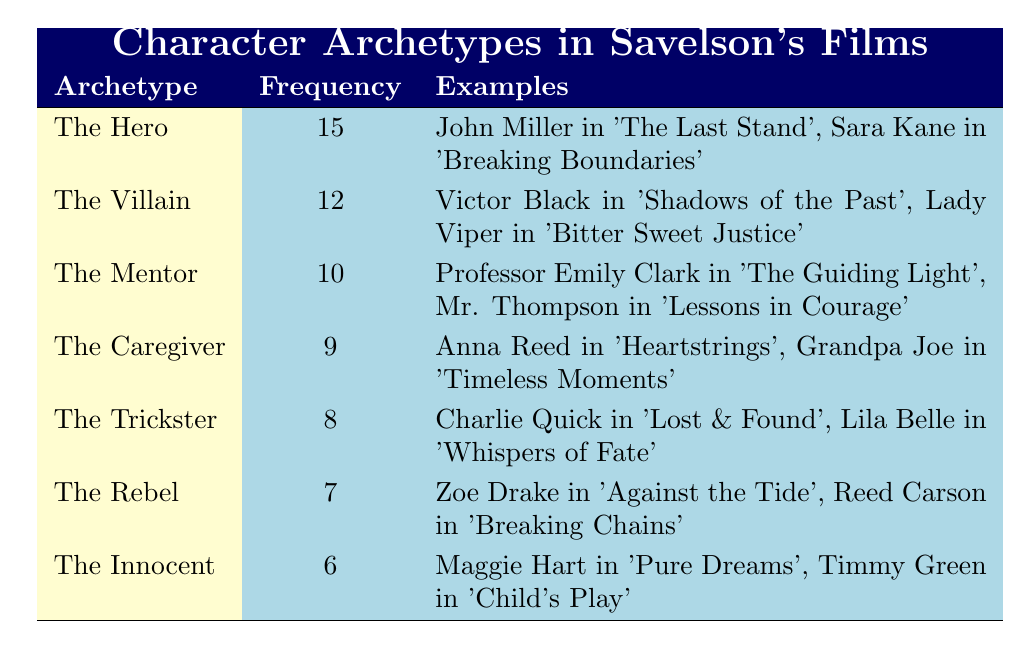What is the archetype with the highest frequency in Savelson's films? The highest frequency listed in the table is 15, which corresponds to "The Hero." To find this, we looked for the row with the highest frequency count.
Answer: The Hero How many examples are given for "The Trickster" archetype? In the table, the "The Trickster" archetype is associated with two examples: Charlie Quick in 'Lost & Found' and Lila Belle in 'Whispers of Fate.'
Answer: 2 What is the frequency of "The Villain" archetype? By looking at the table, "The Villain" has a frequency value of 12, as directly noted in the corresponding row.
Answer: 12 Is "The Caregiver" archetype more frequent than "The Rebel"? "The Caregiver" has a frequency of 9, while "The Rebel" has a frequency of 7. Since 9 is greater than 7, "The Caregiver" is indeed more frequent than "The Rebel."
Answer: Yes What is the total frequency of "The Hero," "The Villain," and "The Mentor"? We sum the frequencies of these three archetypes: 15 (Hero) + 12 (Villain) + 10 (Mentor) = 37. Thus, the total frequency is 37.
Answer: 37 Which archetype has a frequency between 6 and 10? The archetypes "The Caregiver" (9) and "The Mentor" (10) fit this criterion as they have frequencies within the specified range, making them the only archetypes that qualify.
Answer: The Caregiver and The Mentor What is the difference in frequency between "The Hero" and "The Innocent"? We subtract the frequency of "The Innocent" (6) from "The Hero" (15): 15 - 6 = 9. Thus, the difference in frequency is 9.
Answer: 9 Are there more examples for "The Trickster" than for "The Innocent"? Both "The Trickster" and "The Innocent" have two examples each, as listed in their respective rows. Therefore, the statement is false.
Answer: No What is the average frequency of all the archetypes listed? To find the average frequency, we first sum the frequencies: 15 + 12 + 10 + 9 + 8 + 7 + 6 = 67. There are 7 archetypes, so we divide: 67 / 7 ≈ 9.57. The average frequency is approximately 9.57.
Answer: Approximately 9.57 